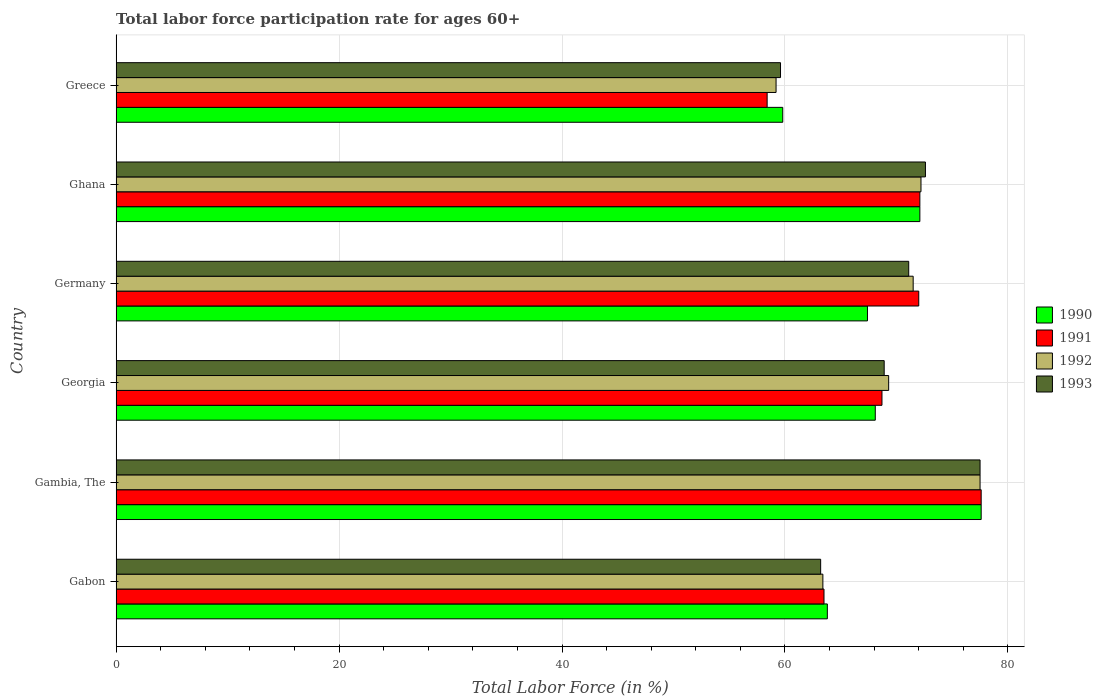How many different coloured bars are there?
Provide a short and direct response. 4. How many groups of bars are there?
Provide a succinct answer. 6. What is the label of the 6th group of bars from the top?
Your answer should be compact. Gabon. What is the labor force participation rate in 1991 in Germany?
Offer a terse response. 72. Across all countries, what is the maximum labor force participation rate in 1990?
Offer a terse response. 77.6. Across all countries, what is the minimum labor force participation rate in 1993?
Provide a succinct answer. 59.6. In which country was the labor force participation rate in 1991 maximum?
Your answer should be compact. Gambia, The. What is the total labor force participation rate in 1991 in the graph?
Keep it short and to the point. 412.3. What is the difference between the labor force participation rate in 1993 in Gambia, The and that in Greece?
Ensure brevity in your answer.  17.9. What is the difference between the labor force participation rate in 1991 in Gambia, The and the labor force participation rate in 1993 in Gabon?
Your answer should be compact. 14.4. What is the average labor force participation rate in 1992 per country?
Ensure brevity in your answer.  68.85. What is the difference between the labor force participation rate in 1990 and labor force participation rate in 1993 in Ghana?
Your response must be concise. -0.5. What is the ratio of the labor force participation rate in 1993 in Georgia to that in Greece?
Your answer should be compact. 1.16. What is the difference between the highest and the lowest labor force participation rate in 1991?
Give a very brief answer. 19.2. In how many countries, is the labor force participation rate in 1993 greater than the average labor force participation rate in 1993 taken over all countries?
Give a very brief answer. 4. Is the sum of the labor force participation rate in 1992 in Gabon and Gambia, The greater than the maximum labor force participation rate in 1990 across all countries?
Offer a terse response. Yes. Is it the case that in every country, the sum of the labor force participation rate in 1991 and labor force participation rate in 1993 is greater than the sum of labor force participation rate in 1990 and labor force participation rate in 1992?
Ensure brevity in your answer.  No. What does the 3rd bar from the bottom in Germany represents?
Offer a terse response. 1992. Is it the case that in every country, the sum of the labor force participation rate in 1991 and labor force participation rate in 1992 is greater than the labor force participation rate in 1993?
Keep it short and to the point. Yes. How many bars are there?
Your answer should be very brief. 24. How many countries are there in the graph?
Your response must be concise. 6. Does the graph contain any zero values?
Ensure brevity in your answer.  No. What is the title of the graph?
Offer a very short reply. Total labor force participation rate for ages 60+. What is the label or title of the X-axis?
Give a very brief answer. Total Labor Force (in %). What is the label or title of the Y-axis?
Your answer should be very brief. Country. What is the Total Labor Force (in %) of 1990 in Gabon?
Offer a terse response. 63.8. What is the Total Labor Force (in %) of 1991 in Gabon?
Give a very brief answer. 63.5. What is the Total Labor Force (in %) of 1992 in Gabon?
Your answer should be compact. 63.4. What is the Total Labor Force (in %) of 1993 in Gabon?
Offer a terse response. 63.2. What is the Total Labor Force (in %) in 1990 in Gambia, The?
Ensure brevity in your answer.  77.6. What is the Total Labor Force (in %) of 1991 in Gambia, The?
Your response must be concise. 77.6. What is the Total Labor Force (in %) in 1992 in Gambia, The?
Give a very brief answer. 77.5. What is the Total Labor Force (in %) in 1993 in Gambia, The?
Offer a very short reply. 77.5. What is the Total Labor Force (in %) in 1990 in Georgia?
Your answer should be compact. 68.1. What is the Total Labor Force (in %) of 1991 in Georgia?
Your answer should be compact. 68.7. What is the Total Labor Force (in %) of 1992 in Georgia?
Give a very brief answer. 69.3. What is the Total Labor Force (in %) in 1993 in Georgia?
Provide a short and direct response. 68.9. What is the Total Labor Force (in %) of 1990 in Germany?
Your response must be concise. 67.4. What is the Total Labor Force (in %) in 1991 in Germany?
Your answer should be very brief. 72. What is the Total Labor Force (in %) in 1992 in Germany?
Your answer should be compact. 71.5. What is the Total Labor Force (in %) of 1993 in Germany?
Offer a very short reply. 71.1. What is the Total Labor Force (in %) of 1990 in Ghana?
Offer a terse response. 72.1. What is the Total Labor Force (in %) of 1991 in Ghana?
Your answer should be compact. 72.1. What is the Total Labor Force (in %) of 1992 in Ghana?
Give a very brief answer. 72.2. What is the Total Labor Force (in %) in 1993 in Ghana?
Ensure brevity in your answer.  72.6. What is the Total Labor Force (in %) of 1990 in Greece?
Your answer should be compact. 59.8. What is the Total Labor Force (in %) in 1991 in Greece?
Provide a succinct answer. 58.4. What is the Total Labor Force (in %) of 1992 in Greece?
Keep it short and to the point. 59.2. What is the Total Labor Force (in %) in 1993 in Greece?
Keep it short and to the point. 59.6. Across all countries, what is the maximum Total Labor Force (in %) of 1990?
Give a very brief answer. 77.6. Across all countries, what is the maximum Total Labor Force (in %) of 1991?
Provide a succinct answer. 77.6. Across all countries, what is the maximum Total Labor Force (in %) in 1992?
Ensure brevity in your answer.  77.5. Across all countries, what is the maximum Total Labor Force (in %) of 1993?
Ensure brevity in your answer.  77.5. Across all countries, what is the minimum Total Labor Force (in %) of 1990?
Make the answer very short. 59.8. Across all countries, what is the minimum Total Labor Force (in %) in 1991?
Your response must be concise. 58.4. Across all countries, what is the minimum Total Labor Force (in %) in 1992?
Your response must be concise. 59.2. Across all countries, what is the minimum Total Labor Force (in %) in 1993?
Offer a terse response. 59.6. What is the total Total Labor Force (in %) of 1990 in the graph?
Your answer should be very brief. 408.8. What is the total Total Labor Force (in %) of 1991 in the graph?
Provide a short and direct response. 412.3. What is the total Total Labor Force (in %) in 1992 in the graph?
Offer a terse response. 413.1. What is the total Total Labor Force (in %) of 1993 in the graph?
Offer a very short reply. 412.9. What is the difference between the Total Labor Force (in %) of 1991 in Gabon and that in Gambia, The?
Provide a succinct answer. -14.1. What is the difference between the Total Labor Force (in %) of 1992 in Gabon and that in Gambia, The?
Make the answer very short. -14.1. What is the difference between the Total Labor Force (in %) in 1993 in Gabon and that in Gambia, The?
Make the answer very short. -14.3. What is the difference between the Total Labor Force (in %) of 1992 in Gabon and that in Georgia?
Offer a terse response. -5.9. What is the difference between the Total Labor Force (in %) of 1993 in Gabon and that in Georgia?
Provide a succinct answer. -5.7. What is the difference between the Total Labor Force (in %) of 1990 in Gabon and that in Germany?
Keep it short and to the point. -3.6. What is the difference between the Total Labor Force (in %) of 1992 in Gabon and that in Germany?
Provide a succinct answer. -8.1. What is the difference between the Total Labor Force (in %) of 1993 in Gabon and that in Greece?
Keep it short and to the point. 3.6. What is the difference between the Total Labor Force (in %) of 1990 in Gambia, The and that in Georgia?
Give a very brief answer. 9.5. What is the difference between the Total Labor Force (in %) of 1992 in Gambia, The and that in Georgia?
Your answer should be compact. 8.2. What is the difference between the Total Labor Force (in %) of 1993 in Gambia, The and that in Georgia?
Ensure brevity in your answer.  8.6. What is the difference between the Total Labor Force (in %) of 1991 in Gambia, The and that in Germany?
Your response must be concise. 5.6. What is the difference between the Total Labor Force (in %) of 1993 in Gambia, The and that in Germany?
Your answer should be compact. 6.4. What is the difference between the Total Labor Force (in %) of 1992 in Gambia, The and that in Ghana?
Give a very brief answer. 5.3. What is the difference between the Total Labor Force (in %) of 1993 in Gambia, The and that in Ghana?
Keep it short and to the point. 4.9. What is the difference between the Total Labor Force (in %) of 1990 in Gambia, The and that in Greece?
Your response must be concise. 17.8. What is the difference between the Total Labor Force (in %) of 1991 in Gambia, The and that in Greece?
Your answer should be very brief. 19.2. What is the difference between the Total Labor Force (in %) in 1990 in Georgia and that in Ghana?
Keep it short and to the point. -4. What is the difference between the Total Labor Force (in %) of 1991 in Georgia and that in Greece?
Make the answer very short. 10.3. What is the difference between the Total Labor Force (in %) in 1993 in Georgia and that in Greece?
Make the answer very short. 9.3. What is the difference between the Total Labor Force (in %) in 1990 in Germany and that in Ghana?
Ensure brevity in your answer.  -4.7. What is the difference between the Total Labor Force (in %) of 1993 in Germany and that in Ghana?
Provide a short and direct response. -1.5. What is the difference between the Total Labor Force (in %) in 1992 in Germany and that in Greece?
Make the answer very short. 12.3. What is the difference between the Total Labor Force (in %) in 1993 in Germany and that in Greece?
Your answer should be very brief. 11.5. What is the difference between the Total Labor Force (in %) of 1990 in Ghana and that in Greece?
Provide a succinct answer. 12.3. What is the difference between the Total Labor Force (in %) of 1991 in Ghana and that in Greece?
Keep it short and to the point. 13.7. What is the difference between the Total Labor Force (in %) of 1990 in Gabon and the Total Labor Force (in %) of 1992 in Gambia, The?
Provide a short and direct response. -13.7. What is the difference between the Total Labor Force (in %) in 1990 in Gabon and the Total Labor Force (in %) in 1993 in Gambia, The?
Your response must be concise. -13.7. What is the difference between the Total Labor Force (in %) of 1991 in Gabon and the Total Labor Force (in %) of 1993 in Gambia, The?
Provide a short and direct response. -14. What is the difference between the Total Labor Force (in %) in 1992 in Gabon and the Total Labor Force (in %) in 1993 in Gambia, The?
Offer a very short reply. -14.1. What is the difference between the Total Labor Force (in %) of 1990 in Gabon and the Total Labor Force (in %) of 1991 in Georgia?
Offer a terse response. -4.9. What is the difference between the Total Labor Force (in %) in 1992 in Gabon and the Total Labor Force (in %) in 1993 in Georgia?
Your answer should be compact. -5.5. What is the difference between the Total Labor Force (in %) in 1990 in Gabon and the Total Labor Force (in %) in 1992 in Germany?
Your response must be concise. -7.7. What is the difference between the Total Labor Force (in %) of 1991 in Gabon and the Total Labor Force (in %) of 1993 in Germany?
Ensure brevity in your answer.  -7.6. What is the difference between the Total Labor Force (in %) in 1990 in Gabon and the Total Labor Force (in %) in 1991 in Ghana?
Ensure brevity in your answer.  -8.3. What is the difference between the Total Labor Force (in %) of 1990 in Gabon and the Total Labor Force (in %) of 1992 in Ghana?
Your answer should be very brief. -8.4. What is the difference between the Total Labor Force (in %) of 1991 in Gabon and the Total Labor Force (in %) of 1992 in Ghana?
Your answer should be very brief. -8.7. What is the difference between the Total Labor Force (in %) of 1992 in Gabon and the Total Labor Force (in %) of 1993 in Ghana?
Your answer should be compact. -9.2. What is the difference between the Total Labor Force (in %) in 1990 in Gabon and the Total Labor Force (in %) in 1993 in Greece?
Ensure brevity in your answer.  4.2. What is the difference between the Total Labor Force (in %) in 1990 in Gambia, The and the Total Labor Force (in %) in 1991 in Georgia?
Ensure brevity in your answer.  8.9. What is the difference between the Total Labor Force (in %) of 1991 in Gambia, The and the Total Labor Force (in %) of 1993 in Georgia?
Provide a succinct answer. 8.7. What is the difference between the Total Labor Force (in %) of 1990 in Gambia, The and the Total Labor Force (in %) of 1993 in Germany?
Your response must be concise. 6.5. What is the difference between the Total Labor Force (in %) of 1991 in Gambia, The and the Total Labor Force (in %) of 1993 in Germany?
Your response must be concise. 6.5. What is the difference between the Total Labor Force (in %) of 1992 in Gambia, The and the Total Labor Force (in %) of 1993 in Germany?
Give a very brief answer. 6.4. What is the difference between the Total Labor Force (in %) in 1992 in Gambia, The and the Total Labor Force (in %) in 1993 in Ghana?
Provide a short and direct response. 4.9. What is the difference between the Total Labor Force (in %) in 1990 in Gambia, The and the Total Labor Force (in %) in 1991 in Greece?
Provide a short and direct response. 19.2. What is the difference between the Total Labor Force (in %) of 1990 in Gambia, The and the Total Labor Force (in %) of 1992 in Greece?
Offer a terse response. 18.4. What is the difference between the Total Labor Force (in %) in 1990 in Gambia, The and the Total Labor Force (in %) in 1993 in Greece?
Your answer should be compact. 18. What is the difference between the Total Labor Force (in %) of 1991 in Gambia, The and the Total Labor Force (in %) of 1992 in Greece?
Provide a succinct answer. 18.4. What is the difference between the Total Labor Force (in %) of 1991 in Gambia, The and the Total Labor Force (in %) of 1993 in Greece?
Your response must be concise. 18. What is the difference between the Total Labor Force (in %) of 1991 in Georgia and the Total Labor Force (in %) of 1992 in Germany?
Provide a short and direct response. -2.8. What is the difference between the Total Labor Force (in %) in 1992 in Georgia and the Total Labor Force (in %) in 1993 in Germany?
Give a very brief answer. -1.8. What is the difference between the Total Labor Force (in %) of 1990 in Georgia and the Total Labor Force (in %) of 1991 in Ghana?
Provide a succinct answer. -4. What is the difference between the Total Labor Force (in %) of 1991 in Georgia and the Total Labor Force (in %) of 1992 in Ghana?
Offer a terse response. -3.5. What is the difference between the Total Labor Force (in %) in 1992 in Georgia and the Total Labor Force (in %) in 1993 in Ghana?
Offer a very short reply. -3.3. What is the difference between the Total Labor Force (in %) of 1990 in Georgia and the Total Labor Force (in %) of 1992 in Greece?
Your answer should be compact. 8.9. What is the difference between the Total Labor Force (in %) of 1991 in Georgia and the Total Labor Force (in %) of 1992 in Greece?
Your answer should be very brief. 9.5. What is the difference between the Total Labor Force (in %) of 1991 in Georgia and the Total Labor Force (in %) of 1993 in Greece?
Keep it short and to the point. 9.1. What is the difference between the Total Labor Force (in %) of 1992 in Georgia and the Total Labor Force (in %) of 1993 in Greece?
Your response must be concise. 9.7. What is the difference between the Total Labor Force (in %) in 1990 in Germany and the Total Labor Force (in %) in 1993 in Ghana?
Your response must be concise. -5.2. What is the difference between the Total Labor Force (in %) in 1991 in Germany and the Total Labor Force (in %) in 1993 in Ghana?
Offer a very short reply. -0.6. What is the difference between the Total Labor Force (in %) of 1992 in Germany and the Total Labor Force (in %) of 1993 in Ghana?
Keep it short and to the point. -1.1. What is the difference between the Total Labor Force (in %) of 1990 in Germany and the Total Labor Force (in %) of 1991 in Greece?
Make the answer very short. 9. What is the difference between the Total Labor Force (in %) in 1990 in Germany and the Total Labor Force (in %) in 1993 in Greece?
Your answer should be very brief. 7.8. What is the difference between the Total Labor Force (in %) in 1991 in Germany and the Total Labor Force (in %) in 1992 in Greece?
Provide a short and direct response. 12.8. What is the difference between the Total Labor Force (in %) of 1991 in Germany and the Total Labor Force (in %) of 1993 in Greece?
Ensure brevity in your answer.  12.4. What is the difference between the Total Labor Force (in %) of 1990 in Ghana and the Total Labor Force (in %) of 1991 in Greece?
Offer a very short reply. 13.7. What is the difference between the Total Labor Force (in %) of 1991 in Ghana and the Total Labor Force (in %) of 1993 in Greece?
Offer a very short reply. 12.5. What is the difference between the Total Labor Force (in %) of 1992 in Ghana and the Total Labor Force (in %) of 1993 in Greece?
Your answer should be compact. 12.6. What is the average Total Labor Force (in %) in 1990 per country?
Ensure brevity in your answer.  68.13. What is the average Total Labor Force (in %) of 1991 per country?
Provide a short and direct response. 68.72. What is the average Total Labor Force (in %) of 1992 per country?
Keep it short and to the point. 68.85. What is the average Total Labor Force (in %) in 1993 per country?
Your answer should be very brief. 68.82. What is the difference between the Total Labor Force (in %) of 1990 and Total Labor Force (in %) of 1991 in Gabon?
Give a very brief answer. 0.3. What is the difference between the Total Labor Force (in %) in 1990 and Total Labor Force (in %) in 1992 in Gabon?
Keep it short and to the point. 0.4. What is the difference between the Total Labor Force (in %) of 1990 and Total Labor Force (in %) of 1993 in Gabon?
Your response must be concise. 0.6. What is the difference between the Total Labor Force (in %) in 1991 and Total Labor Force (in %) in 1992 in Gabon?
Offer a terse response. 0.1. What is the difference between the Total Labor Force (in %) in 1991 and Total Labor Force (in %) in 1993 in Gabon?
Make the answer very short. 0.3. What is the difference between the Total Labor Force (in %) of 1990 and Total Labor Force (in %) of 1993 in Gambia, The?
Offer a terse response. 0.1. What is the difference between the Total Labor Force (in %) of 1991 and Total Labor Force (in %) of 1993 in Gambia, The?
Your answer should be very brief. 0.1. What is the difference between the Total Labor Force (in %) of 1990 and Total Labor Force (in %) of 1992 in Georgia?
Your answer should be compact. -1.2. What is the difference between the Total Labor Force (in %) in 1991 and Total Labor Force (in %) in 1992 in Georgia?
Your response must be concise. -0.6. What is the difference between the Total Labor Force (in %) in 1991 and Total Labor Force (in %) in 1993 in Georgia?
Provide a short and direct response. -0.2. What is the difference between the Total Labor Force (in %) in 1990 and Total Labor Force (in %) in 1992 in Germany?
Give a very brief answer. -4.1. What is the difference between the Total Labor Force (in %) of 1990 and Total Labor Force (in %) of 1993 in Germany?
Provide a succinct answer. -3.7. What is the difference between the Total Labor Force (in %) of 1991 and Total Labor Force (in %) of 1993 in Germany?
Provide a succinct answer. 0.9. What is the difference between the Total Labor Force (in %) of 1990 and Total Labor Force (in %) of 1992 in Ghana?
Your answer should be compact. -0.1. What is the difference between the Total Labor Force (in %) of 1991 and Total Labor Force (in %) of 1992 in Ghana?
Offer a very short reply. -0.1. What is the difference between the Total Labor Force (in %) of 1991 and Total Labor Force (in %) of 1993 in Ghana?
Your response must be concise. -0.5. What is the difference between the Total Labor Force (in %) in 1992 and Total Labor Force (in %) in 1993 in Ghana?
Ensure brevity in your answer.  -0.4. What is the difference between the Total Labor Force (in %) in 1990 and Total Labor Force (in %) in 1993 in Greece?
Keep it short and to the point. 0.2. What is the difference between the Total Labor Force (in %) of 1991 and Total Labor Force (in %) of 1993 in Greece?
Keep it short and to the point. -1.2. What is the ratio of the Total Labor Force (in %) in 1990 in Gabon to that in Gambia, The?
Your answer should be very brief. 0.82. What is the ratio of the Total Labor Force (in %) of 1991 in Gabon to that in Gambia, The?
Give a very brief answer. 0.82. What is the ratio of the Total Labor Force (in %) of 1992 in Gabon to that in Gambia, The?
Your response must be concise. 0.82. What is the ratio of the Total Labor Force (in %) of 1993 in Gabon to that in Gambia, The?
Make the answer very short. 0.82. What is the ratio of the Total Labor Force (in %) of 1990 in Gabon to that in Georgia?
Your response must be concise. 0.94. What is the ratio of the Total Labor Force (in %) in 1991 in Gabon to that in Georgia?
Make the answer very short. 0.92. What is the ratio of the Total Labor Force (in %) of 1992 in Gabon to that in Georgia?
Your answer should be very brief. 0.91. What is the ratio of the Total Labor Force (in %) in 1993 in Gabon to that in Georgia?
Offer a terse response. 0.92. What is the ratio of the Total Labor Force (in %) of 1990 in Gabon to that in Germany?
Offer a very short reply. 0.95. What is the ratio of the Total Labor Force (in %) of 1991 in Gabon to that in Germany?
Keep it short and to the point. 0.88. What is the ratio of the Total Labor Force (in %) of 1992 in Gabon to that in Germany?
Ensure brevity in your answer.  0.89. What is the ratio of the Total Labor Force (in %) of 1990 in Gabon to that in Ghana?
Offer a very short reply. 0.88. What is the ratio of the Total Labor Force (in %) of 1991 in Gabon to that in Ghana?
Ensure brevity in your answer.  0.88. What is the ratio of the Total Labor Force (in %) of 1992 in Gabon to that in Ghana?
Your answer should be compact. 0.88. What is the ratio of the Total Labor Force (in %) in 1993 in Gabon to that in Ghana?
Keep it short and to the point. 0.87. What is the ratio of the Total Labor Force (in %) in 1990 in Gabon to that in Greece?
Your response must be concise. 1.07. What is the ratio of the Total Labor Force (in %) in 1991 in Gabon to that in Greece?
Your answer should be compact. 1.09. What is the ratio of the Total Labor Force (in %) of 1992 in Gabon to that in Greece?
Ensure brevity in your answer.  1.07. What is the ratio of the Total Labor Force (in %) in 1993 in Gabon to that in Greece?
Keep it short and to the point. 1.06. What is the ratio of the Total Labor Force (in %) of 1990 in Gambia, The to that in Georgia?
Keep it short and to the point. 1.14. What is the ratio of the Total Labor Force (in %) in 1991 in Gambia, The to that in Georgia?
Make the answer very short. 1.13. What is the ratio of the Total Labor Force (in %) of 1992 in Gambia, The to that in Georgia?
Offer a very short reply. 1.12. What is the ratio of the Total Labor Force (in %) in 1993 in Gambia, The to that in Georgia?
Give a very brief answer. 1.12. What is the ratio of the Total Labor Force (in %) of 1990 in Gambia, The to that in Germany?
Make the answer very short. 1.15. What is the ratio of the Total Labor Force (in %) of 1991 in Gambia, The to that in Germany?
Your response must be concise. 1.08. What is the ratio of the Total Labor Force (in %) in 1992 in Gambia, The to that in Germany?
Provide a succinct answer. 1.08. What is the ratio of the Total Labor Force (in %) in 1993 in Gambia, The to that in Germany?
Your answer should be very brief. 1.09. What is the ratio of the Total Labor Force (in %) in 1990 in Gambia, The to that in Ghana?
Your answer should be very brief. 1.08. What is the ratio of the Total Labor Force (in %) of 1991 in Gambia, The to that in Ghana?
Keep it short and to the point. 1.08. What is the ratio of the Total Labor Force (in %) in 1992 in Gambia, The to that in Ghana?
Keep it short and to the point. 1.07. What is the ratio of the Total Labor Force (in %) of 1993 in Gambia, The to that in Ghana?
Make the answer very short. 1.07. What is the ratio of the Total Labor Force (in %) in 1990 in Gambia, The to that in Greece?
Offer a very short reply. 1.3. What is the ratio of the Total Labor Force (in %) of 1991 in Gambia, The to that in Greece?
Make the answer very short. 1.33. What is the ratio of the Total Labor Force (in %) of 1992 in Gambia, The to that in Greece?
Offer a terse response. 1.31. What is the ratio of the Total Labor Force (in %) in 1993 in Gambia, The to that in Greece?
Offer a terse response. 1.3. What is the ratio of the Total Labor Force (in %) in 1990 in Georgia to that in Germany?
Provide a short and direct response. 1.01. What is the ratio of the Total Labor Force (in %) of 1991 in Georgia to that in Germany?
Your response must be concise. 0.95. What is the ratio of the Total Labor Force (in %) in 1992 in Georgia to that in Germany?
Keep it short and to the point. 0.97. What is the ratio of the Total Labor Force (in %) in 1993 in Georgia to that in Germany?
Ensure brevity in your answer.  0.97. What is the ratio of the Total Labor Force (in %) in 1990 in Georgia to that in Ghana?
Your answer should be compact. 0.94. What is the ratio of the Total Labor Force (in %) of 1991 in Georgia to that in Ghana?
Keep it short and to the point. 0.95. What is the ratio of the Total Labor Force (in %) of 1992 in Georgia to that in Ghana?
Provide a succinct answer. 0.96. What is the ratio of the Total Labor Force (in %) in 1993 in Georgia to that in Ghana?
Your answer should be compact. 0.95. What is the ratio of the Total Labor Force (in %) of 1990 in Georgia to that in Greece?
Ensure brevity in your answer.  1.14. What is the ratio of the Total Labor Force (in %) in 1991 in Georgia to that in Greece?
Give a very brief answer. 1.18. What is the ratio of the Total Labor Force (in %) of 1992 in Georgia to that in Greece?
Provide a succinct answer. 1.17. What is the ratio of the Total Labor Force (in %) in 1993 in Georgia to that in Greece?
Your answer should be very brief. 1.16. What is the ratio of the Total Labor Force (in %) in 1990 in Germany to that in Ghana?
Your response must be concise. 0.93. What is the ratio of the Total Labor Force (in %) in 1992 in Germany to that in Ghana?
Keep it short and to the point. 0.99. What is the ratio of the Total Labor Force (in %) in 1993 in Germany to that in Ghana?
Your response must be concise. 0.98. What is the ratio of the Total Labor Force (in %) in 1990 in Germany to that in Greece?
Your answer should be compact. 1.13. What is the ratio of the Total Labor Force (in %) of 1991 in Germany to that in Greece?
Keep it short and to the point. 1.23. What is the ratio of the Total Labor Force (in %) of 1992 in Germany to that in Greece?
Keep it short and to the point. 1.21. What is the ratio of the Total Labor Force (in %) in 1993 in Germany to that in Greece?
Ensure brevity in your answer.  1.19. What is the ratio of the Total Labor Force (in %) in 1990 in Ghana to that in Greece?
Provide a succinct answer. 1.21. What is the ratio of the Total Labor Force (in %) in 1991 in Ghana to that in Greece?
Make the answer very short. 1.23. What is the ratio of the Total Labor Force (in %) in 1992 in Ghana to that in Greece?
Your answer should be compact. 1.22. What is the ratio of the Total Labor Force (in %) in 1993 in Ghana to that in Greece?
Ensure brevity in your answer.  1.22. What is the difference between the highest and the second highest Total Labor Force (in %) in 1990?
Give a very brief answer. 5.5. What is the difference between the highest and the second highest Total Labor Force (in %) of 1992?
Give a very brief answer. 5.3. What is the difference between the highest and the second highest Total Labor Force (in %) in 1993?
Your answer should be very brief. 4.9. What is the difference between the highest and the lowest Total Labor Force (in %) of 1990?
Your answer should be very brief. 17.8. What is the difference between the highest and the lowest Total Labor Force (in %) in 1993?
Your answer should be very brief. 17.9. 